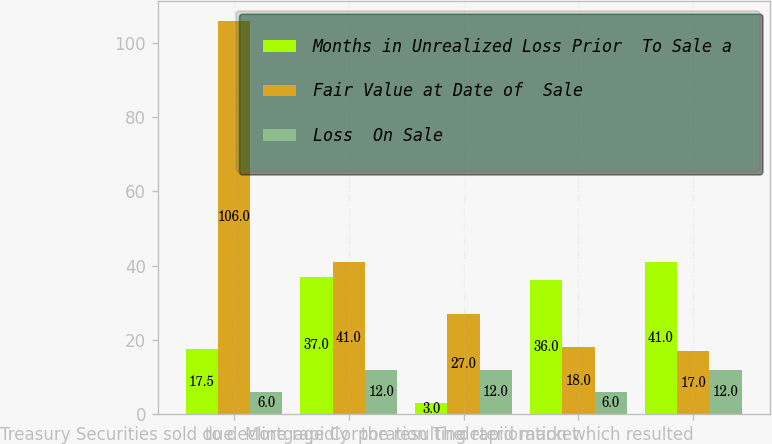Convert chart to OTSL. <chart><loc_0><loc_0><loc_500><loc_500><stacked_bar_chart><ecel><fcel>Treasury Securities sold due<fcel>to decline rapidly<fcel>Mortgage Corporation The<fcel>the resulting rapid market<fcel>deterioration which resulted<nl><fcel>Months in Unrealized Loss Prior  To Sale a<fcel>17.5<fcel>37<fcel>3<fcel>36<fcel>41<nl><fcel>Fair Value at Date of  Sale<fcel>106<fcel>41<fcel>27<fcel>18<fcel>17<nl><fcel>Loss  On Sale<fcel>6<fcel>12<fcel>12<fcel>6<fcel>12<nl></chart> 